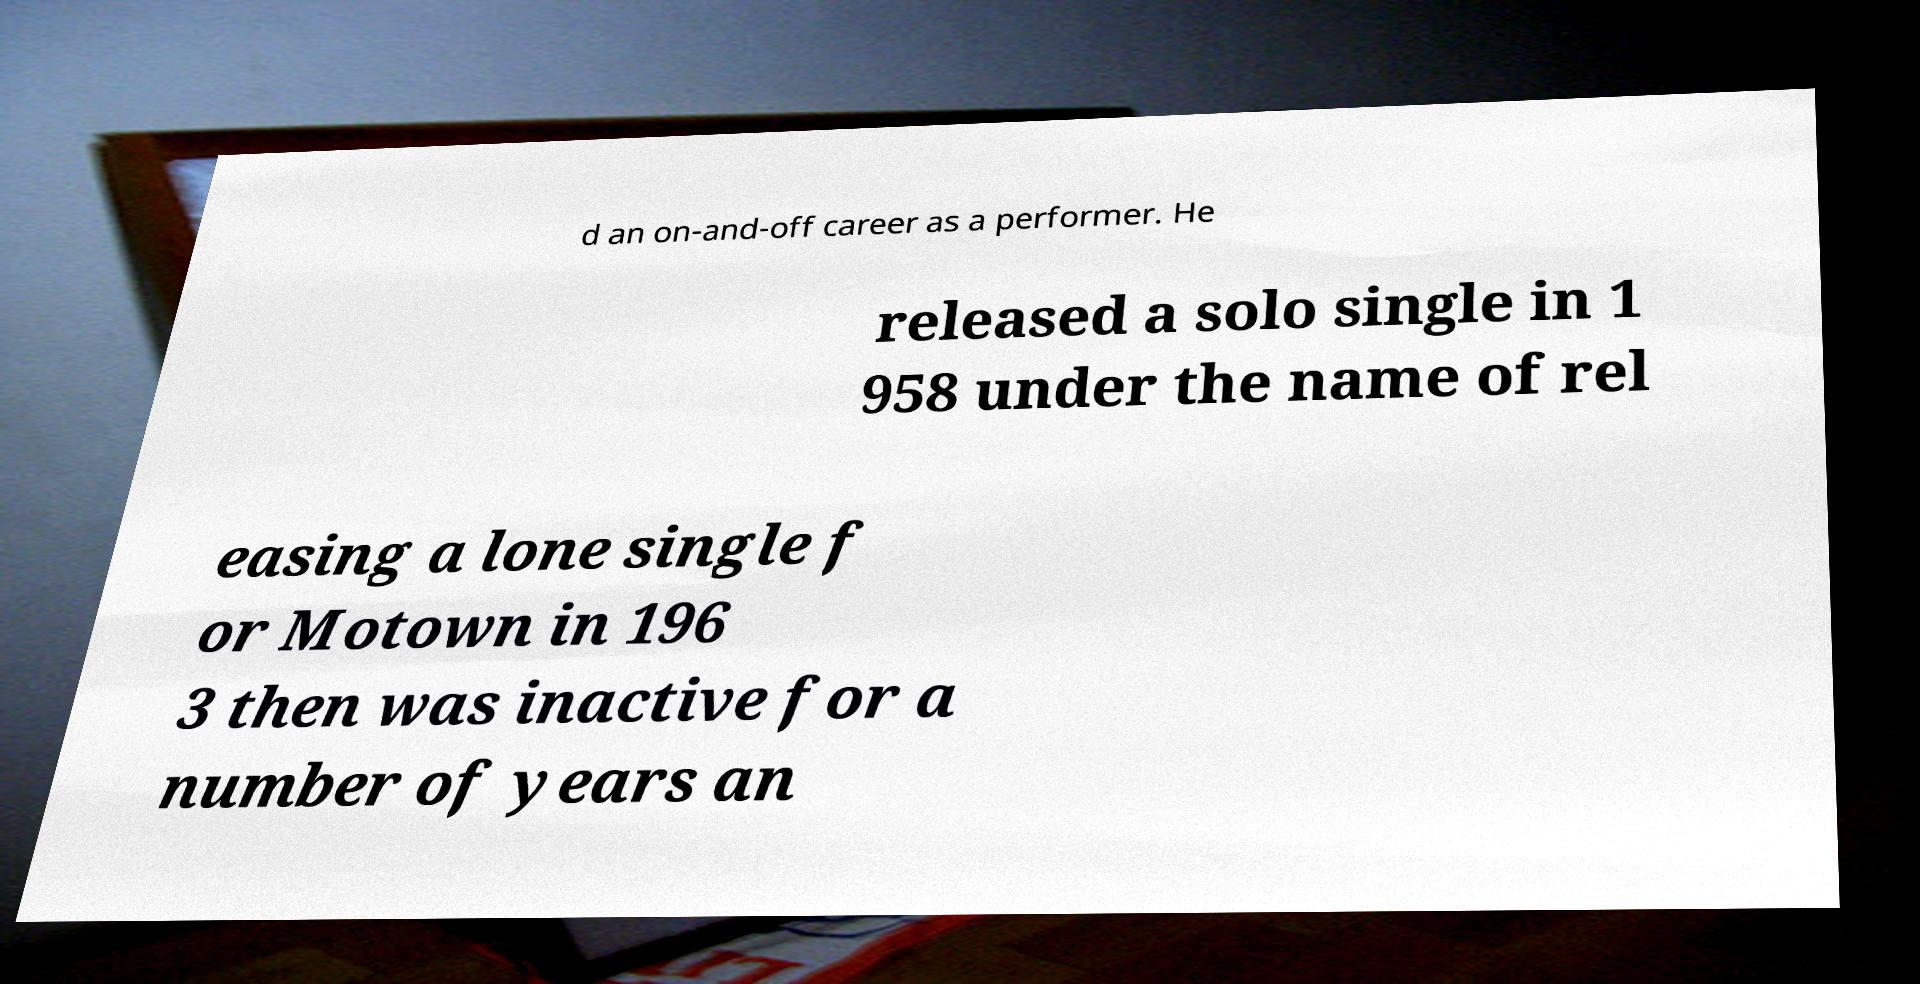I need the written content from this picture converted into text. Can you do that? d an on-and-off career as a performer. He released a solo single in 1 958 under the name of rel easing a lone single f or Motown in 196 3 then was inactive for a number of years an 